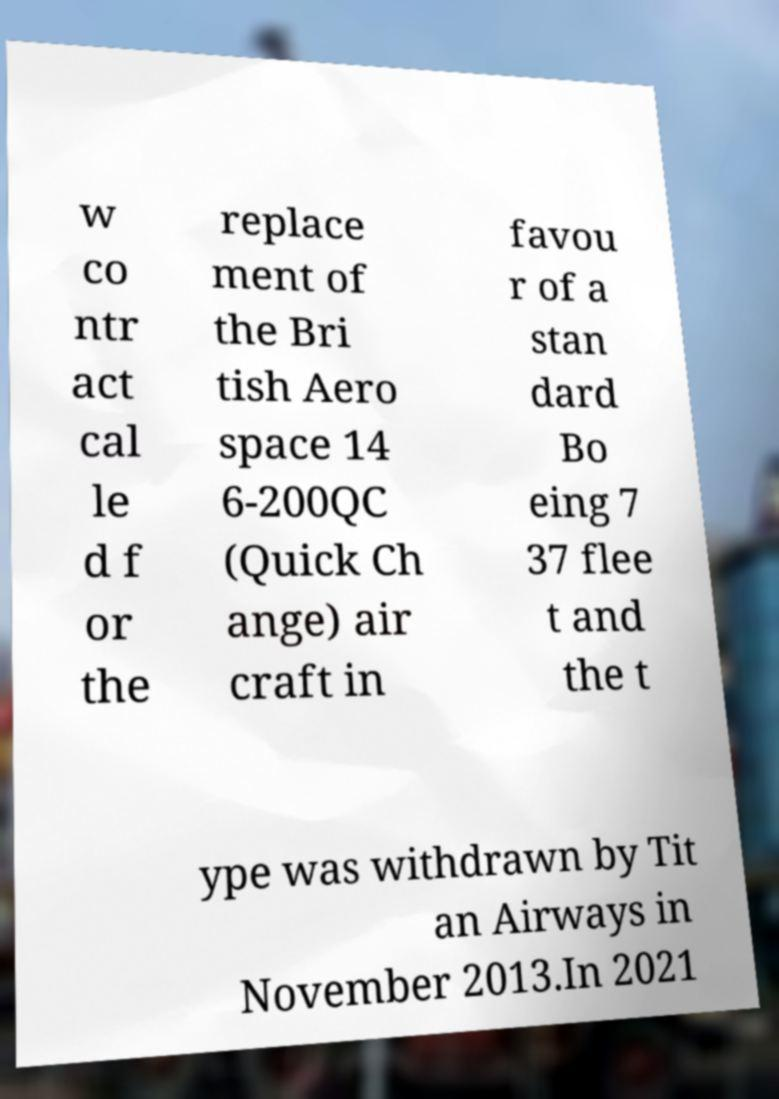For documentation purposes, I need the text within this image transcribed. Could you provide that? w co ntr act cal le d f or the replace ment of the Bri tish Aero space 14 6-200QC (Quick Ch ange) air craft in favou r of a stan dard Bo eing 7 37 flee t and the t ype was withdrawn by Tit an Airways in November 2013.In 2021 